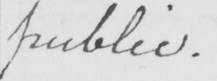Can you tell me what this handwritten text says? public . 